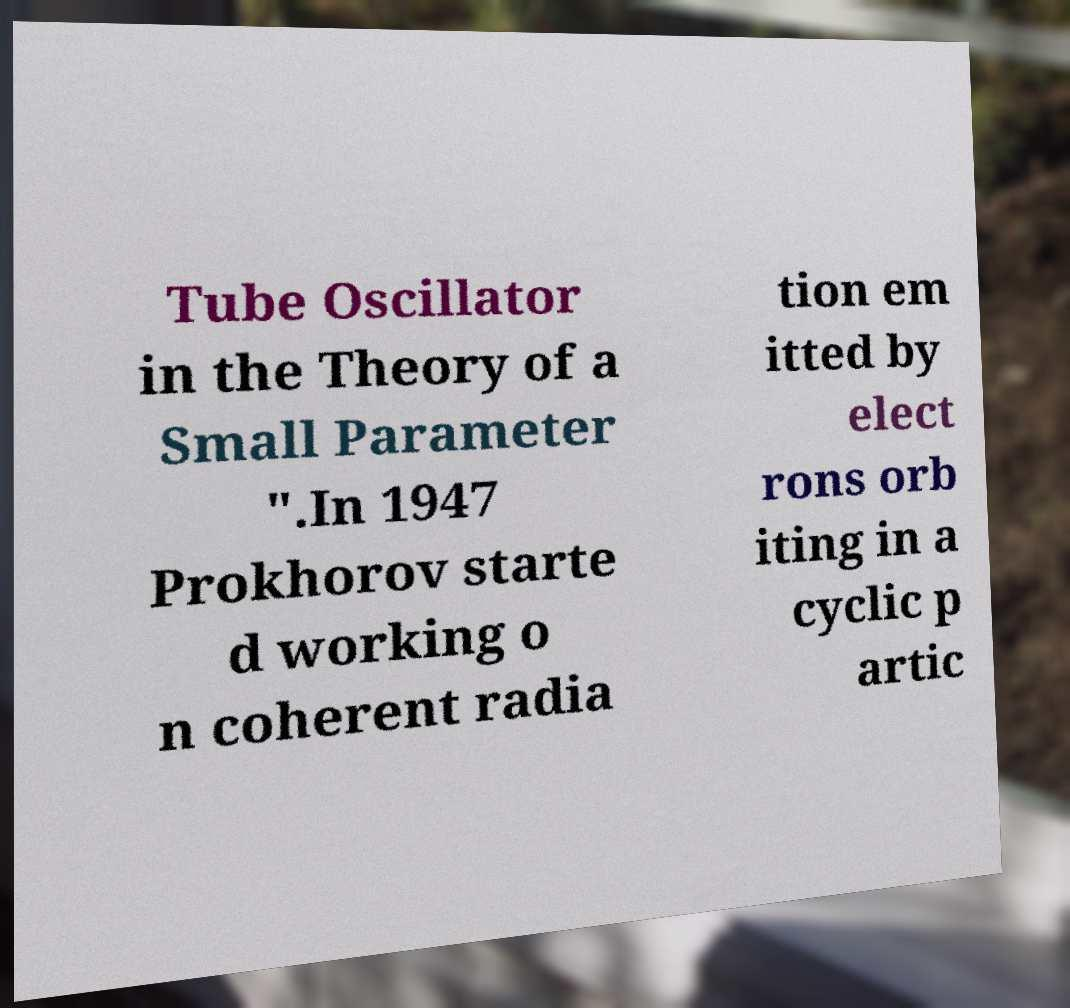Could you extract and type out the text from this image? Tube Oscillator in the Theory of a Small Parameter ".In 1947 Prokhorov starte d working o n coherent radia tion em itted by elect rons orb iting in a cyclic p artic 